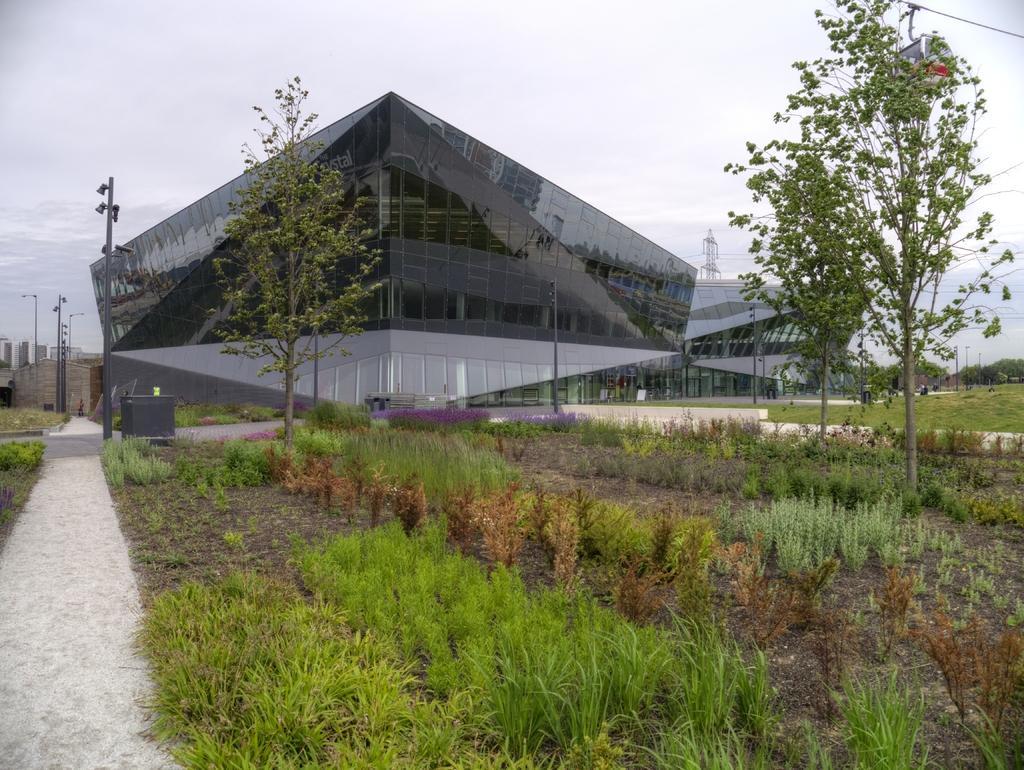Please provide a concise description of this image. In this image we can see plants and trees. In the back there are poles. Also we can see a buildings. And there is a tower. In the background there is sky. 